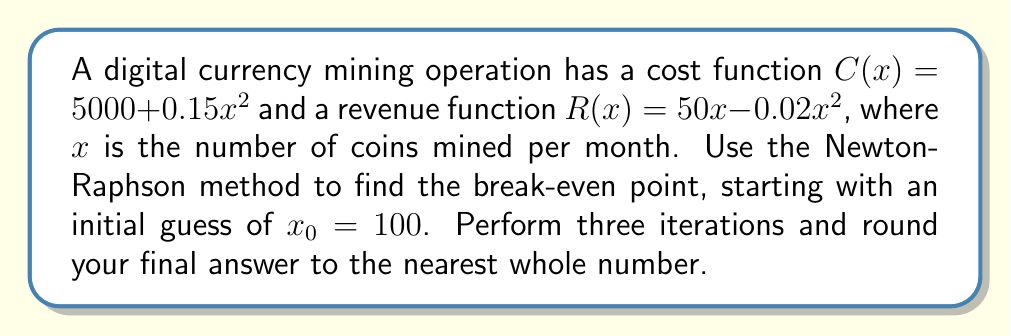Could you help me with this problem? To find the break-even point, we need to solve the equation $C(x) = R(x)$:

$$5000 + 0.15x^2 = 50x - 0.02x^2$$

Rearranging to standard form $f(x) = 0$:

$$f(x) = 0.17x^2 - 50x + 5000 = 0$$

The Newton-Raphson method is given by:

$$x_{n+1} = x_n - \frac{f(x_n)}{f'(x_n)}$$

We need $f(x)$ and $f'(x)$:

$$f(x) = 0.17x^2 - 50x + 5000$$
$$f'(x) = 0.34x - 50$$

Starting with $x_0 = 100$:

Iteration 1:
$$f(100) = 0.17(100)^2 - 50(100) + 5000 = 1700 - 5000 + 5000 = 1700$$
$$f'(100) = 0.34(100) - 50 = -16$$
$$x_1 = 100 - \frac{1700}{-16} = 206.25$$

Iteration 2:
$$f(206.25) = 0.17(206.25)^2 - 50(206.25) + 5000 \approx 2133.49$$
$$f'(206.25) = 0.34(206.25) - 50 \approx 20.13$$
$$x_2 = 206.25 - \frac{2133.49}{20.13} \approx 100.31$$

Iteration 3:
$$f(100.31) = 0.17(100.31)^2 - 50(100.31) + 5000 \approx 62.10$$
$$f'(100.31) = 0.34(100.31) - 50 \approx -15.89$$
$$x_3 = 100.31 - \frac{62.10}{-15.89} \approx 104.22$$

Rounding to the nearest whole number, we get 104.
Answer: 104 coins 